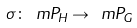Convert formula to latex. <formula><loc_0><loc_0><loc_500><loc_500>\sigma \colon \ m { P } _ { H } \rightarrow \ m { P } _ { G }</formula> 